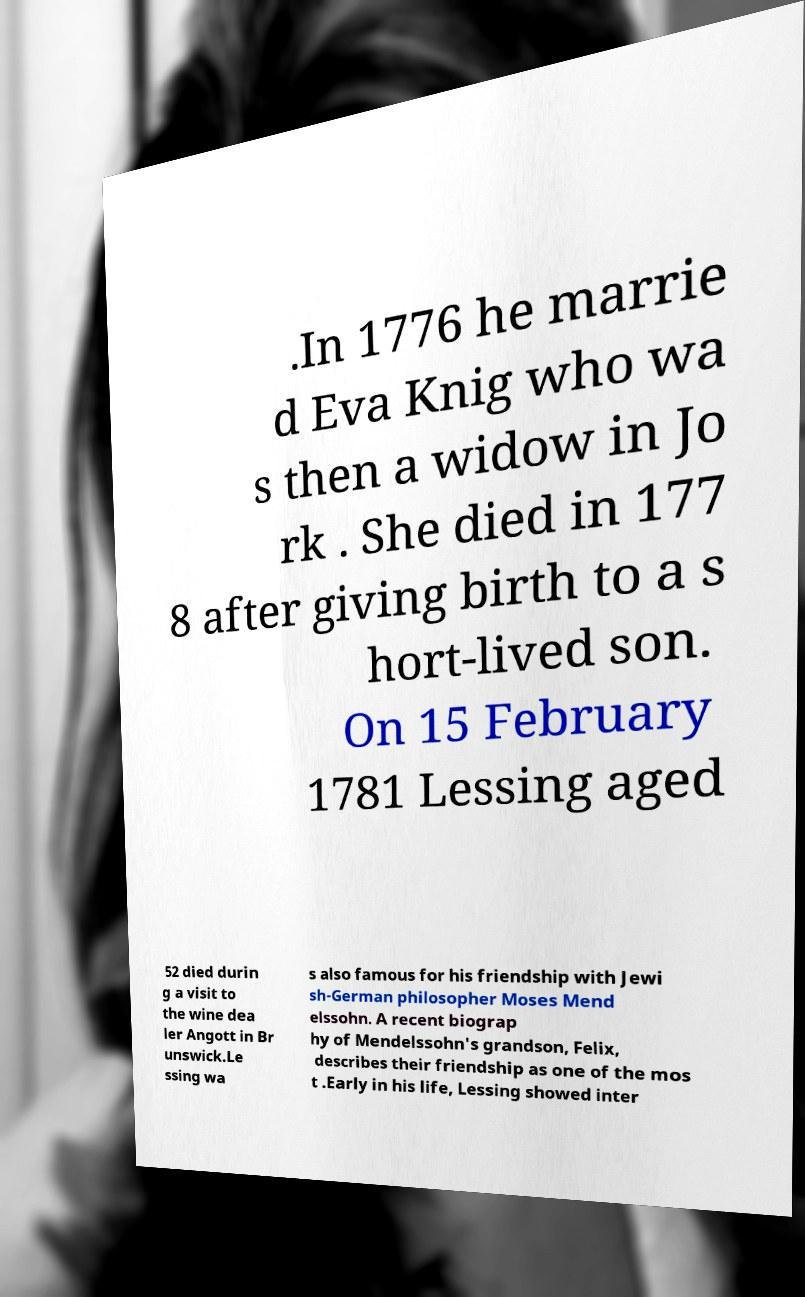For documentation purposes, I need the text within this image transcribed. Could you provide that? .In 1776 he marrie d Eva Knig who wa s then a widow in Jo rk . She died in 177 8 after giving birth to a s hort-lived son. On 15 February 1781 Lessing aged 52 died durin g a visit to the wine dea ler Angott in Br unswick.Le ssing wa s also famous for his friendship with Jewi sh-German philosopher Moses Mend elssohn. A recent biograp hy of Mendelssohn's grandson, Felix, describes their friendship as one of the mos t .Early in his life, Lessing showed inter 